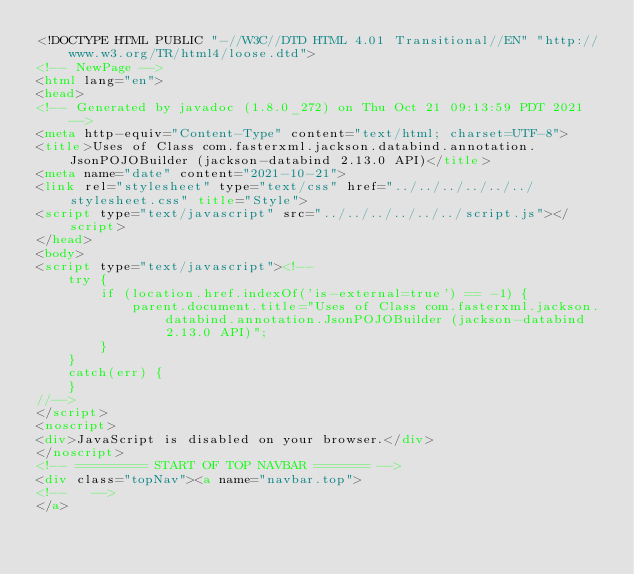<code> <loc_0><loc_0><loc_500><loc_500><_HTML_><!DOCTYPE HTML PUBLIC "-//W3C//DTD HTML 4.01 Transitional//EN" "http://www.w3.org/TR/html4/loose.dtd">
<!-- NewPage -->
<html lang="en">
<head>
<!-- Generated by javadoc (1.8.0_272) on Thu Oct 21 09:13:59 PDT 2021 -->
<meta http-equiv="Content-Type" content="text/html; charset=UTF-8">
<title>Uses of Class com.fasterxml.jackson.databind.annotation.JsonPOJOBuilder (jackson-databind 2.13.0 API)</title>
<meta name="date" content="2021-10-21">
<link rel="stylesheet" type="text/css" href="../../../../../../stylesheet.css" title="Style">
<script type="text/javascript" src="../../../../../../script.js"></script>
</head>
<body>
<script type="text/javascript"><!--
    try {
        if (location.href.indexOf('is-external=true') == -1) {
            parent.document.title="Uses of Class com.fasterxml.jackson.databind.annotation.JsonPOJOBuilder (jackson-databind 2.13.0 API)";
        }
    }
    catch(err) {
    }
//-->
</script>
<noscript>
<div>JavaScript is disabled on your browser.</div>
</noscript>
<!-- ========= START OF TOP NAVBAR ======= -->
<div class="topNav"><a name="navbar.top">
<!--   -->
</a></code> 